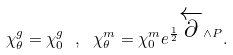<formula> <loc_0><loc_0><loc_500><loc_500>\chi _ { \theta } ^ { g } = \chi _ { 0 } ^ { g } \ , \ \chi _ { \theta } ^ { m } = \chi _ { 0 } ^ { m } e ^ { \frac { 1 } { 2 } \overleftarrow { \partial } \wedge P } .</formula> 